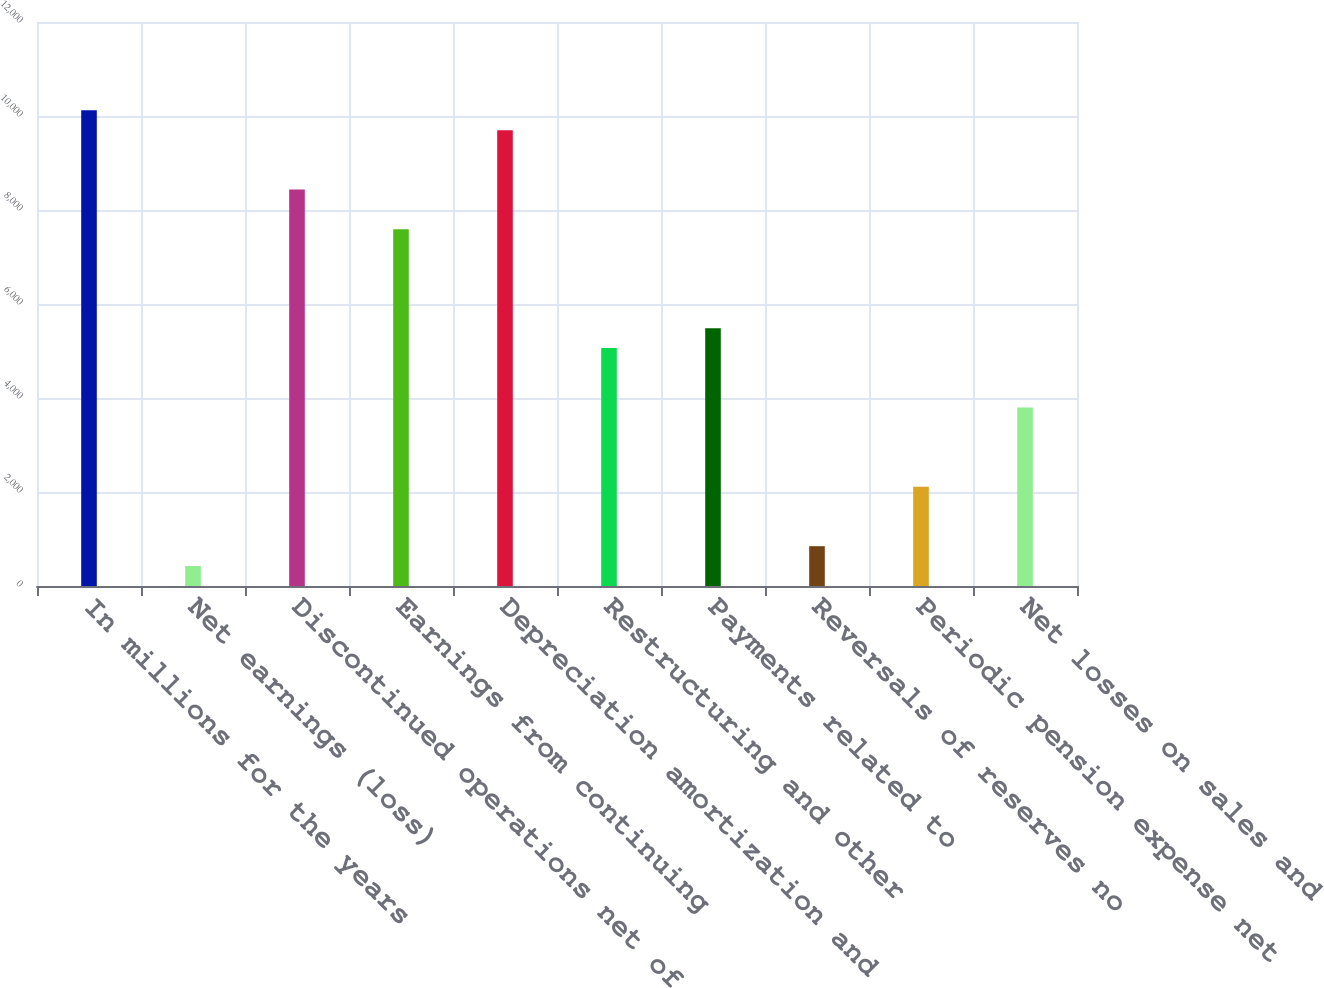Convert chart. <chart><loc_0><loc_0><loc_500><loc_500><bar_chart><fcel>In millions for the years<fcel>Net earnings (loss)<fcel>Discontinued operations net of<fcel>Earnings from continuing<fcel>Depreciation amortization and<fcel>Restructuring and other<fcel>Payments related to<fcel>Reversals of reserves no<fcel>Periodic pension expense net<fcel>Net losses on sales and<nl><fcel>10120<fcel>425.5<fcel>8434<fcel>7591<fcel>9698.5<fcel>5062<fcel>5483.5<fcel>847<fcel>2111.5<fcel>3797.5<nl></chart> 